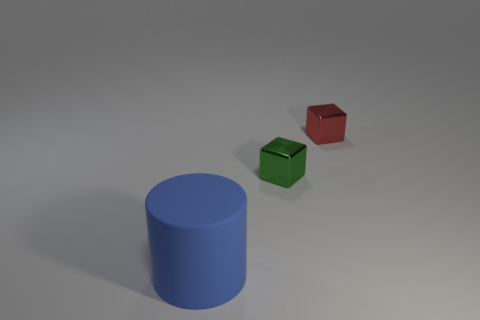Is there anything else that is the same size as the blue rubber cylinder?
Your answer should be compact. No. What number of cylinders are big things or metal objects?
Give a very brief answer. 1. Do the thing right of the green block and the small shiny object on the left side of the red shiny cube have the same shape?
Give a very brief answer. Yes. What color is the thing that is in front of the red block and behind the rubber cylinder?
Offer a terse response. Green. There is a thing that is in front of the red thing and behind the big thing; what is its size?
Make the answer very short. Small. What number of other objects are the same color as the large thing?
Give a very brief answer. 0. There is a cube that is behind the tiny shiny object that is in front of the small cube that is behind the green thing; how big is it?
Keep it short and to the point. Small. There is a green shiny cube; are there any tiny red things in front of it?
Provide a succinct answer. No. Does the green metal block have the same size as the matte object that is to the left of the tiny red metal block?
Provide a succinct answer. No. What number of other objects are the same material as the cylinder?
Ensure brevity in your answer.  0. 